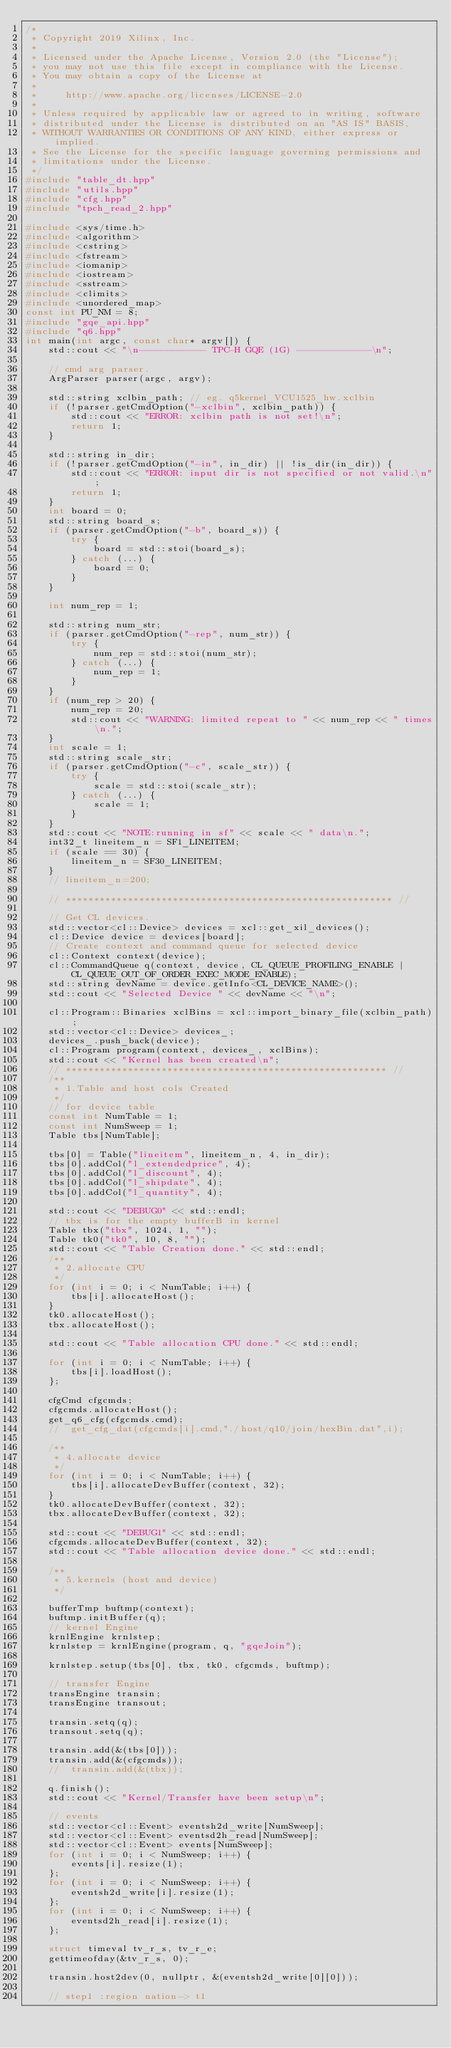Convert code to text. <code><loc_0><loc_0><loc_500><loc_500><_C++_>/*
 * Copyright 2019 Xilinx, Inc.
 *
 * Licensed under the Apache License, Version 2.0 (the "License");
 * you may not use this file except in compliance with the License.
 * You may obtain a copy of the License at
 *
 *     http://www.apache.org/licenses/LICENSE-2.0
 *
 * Unless required by applicable law or agreed to in writing, software
 * distributed under the License is distributed on an "AS IS" BASIS,
 * WITHOUT WARRANTIES OR CONDITIONS OF ANY KIND, either express or implied.
 * See the License for the specific language governing permissions and
 * limitations under the License.
 */
#include "table_dt.hpp"
#include "utils.hpp"
#include "cfg.hpp"
#include "tpch_read_2.hpp"

#include <sys/time.h>
#include <algorithm>
#include <cstring>
#include <fstream>
#include <iomanip>
#include <iostream>
#include <sstream>
#include <climits>
#include <unordered_map>
const int PU_NM = 8;
#include "gqe_api.hpp"
#include "q6.hpp"
int main(int argc, const char* argv[]) {
    std::cout << "\n------------ TPC-H GQE (1G) -------------\n";

    // cmd arg parser.
    ArgParser parser(argc, argv);

    std::string xclbin_path; // eg. q5kernel_VCU1525_hw.xclbin
    if (!parser.getCmdOption("-xclbin", xclbin_path)) {
        std::cout << "ERROR: xclbin path is not set!\n";
        return 1;
    }

    std::string in_dir;
    if (!parser.getCmdOption("-in", in_dir) || !is_dir(in_dir)) {
        std::cout << "ERROR: input dir is not specified or not valid.\n";
        return 1;
    }
    int board = 0;
    std::string board_s;
    if (parser.getCmdOption("-b", board_s)) {
        try {
            board = std::stoi(board_s);
        } catch (...) {
            board = 0;
        }
    }

    int num_rep = 1;

    std::string num_str;
    if (parser.getCmdOption("-rep", num_str)) {
        try {
            num_rep = std::stoi(num_str);
        } catch (...) {
            num_rep = 1;
        }
    }
    if (num_rep > 20) {
        num_rep = 20;
        std::cout << "WARNING: limited repeat to " << num_rep << " times\n.";
    }
    int scale = 1;
    std::string scale_str;
    if (parser.getCmdOption("-c", scale_str)) {
        try {
            scale = std::stoi(scale_str);
        } catch (...) {
            scale = 1;
        }
    }
    std::cout << "NOTE:running in sf" << scale << " data\n.";
    int32_t lineitem_n = SF1_LINEITEM;
    if (scale == 30) {
        lineitem_n = SF30_LINEITEM;
    }
    // lineitem_n=200;

    // ********************************************************** //

    // Get CL devices.
    std::vector<cl::Device> devices = xcl::get_xil_devices();
    cl::Device device = devices[board];
    // Create context and command queue for selected device
    cl::Context context(device);
    cl::CommandQueue q(context, device, CL_QUEUE_PROFILING_ENABLE | CL_QUEUE_OUT_OF_ORDER_EXEC_MODE_ENABLE);
    std::string devName = device.getInfo<CL_DEVICE_NAME>();
    std::cout << "Selected Device " << devName << "\n";

    cl::Program::Binaries xclBins = xcl::import_binary_file(xclbin_path);
    std::vector<cl::Device> devices_;
    devices_.push_back(device);
    cl::Program program(context, devices_, xclBins);
    std::cout << "Kernel has been created\n";
    // ********************************************************* //
    /**
     * 1.Table and host cols Created
     */
    // for device table
    const int NumTable = 1;
    const int NumSweep = 1;
    Table tbs[NumTable];

    tbs[0] = Table("lineitem", lineitem_n, 4, in_dir);
    tbs[0].addCol("l_extendedprice", 4);
    tbs[0].addCol("l_discount", 4);
    tbs[0].addCol("l_shipdate", 4);
    tbs[0].addCol("l_quantity", 4);

    std::cout << "DEBUG0" << std::endl;
    // tbx is for the empty bufferB in kernel
    Table tbx("tbx", 1024, 1, "");
    Table tk0("tk0", 10, 8, "");
    std::cout << "Table Creation done." << std::endl;
    /**
     * 2.allocate CPU
     */
    for (int i = 0; i < NumTable; i++) {
        tbs[i].allocateHost();
    }
    tk0.allocateHost();
    tbx.allocateHost();

    std::cout << "Table allocation CPU done." << std::endl;

    for (int i = 0; i < NumTable; i++) {
        tbs[i].loadHost();
    };

    cfgCmd cfgcmds;
    cfgcmds.allocateHost();
    get_q6_cfg(cfgcmds.cmd);
    //  get_cfg_dat(cfgcmds[i].cmd,"./host/q10/join/hexBin.dat",i);

    /**
     * 4.allocate device
     */
    for (int i = 0; i < NumTable; i++) {
        tbs[i].allocateDevBuffer(context, 32);
    }
    tk0.allocateDevBuffer(context, 32);
    tbx.allocateDevBuffer(context, 32);

    std::cout << "DEBUG1" << std::endl;
    cfgcmds.allocateDevBuffer(context, 32);
    std::cout << "Table allocation device done." << std::endl;

    /**
     * 5.kernels (host and device)
     */

    bufferTmp buftmp(context);
    buftmp.initBuffer(q);
    // kernel Engine
    krnlEngine krnlstep;
    krnlstep = krnlEngine(program, q, "gqeJoin");

    krnlstep.setup(tbs[0], tbx, tk0, cfgcmds, buftmp);

    // transfer Engine
    transEngine transin;
    transEngine transout;

    transin.setq(q);
    transout.setq(q);

    transin.add(&(tbs[0]));
    transin.add(&(cfgcmds));
    //  transin.add(&(tbx));

    q.finish();
    std::cout << "Kernel/Transfer have been setup\n";

    // events
    std::vector<cl::Event> eventsh2d_write[NumSweep];
    std::vector<cl::Event> eventsd2h_read[NumSweep];
    std::vector<cl::Event> events[NumSweep];
    for (int i = 0; i < NumSweep; i++) {
        events[i].resize(1);
    };
    for (int i = 0; i < NumSweep; i++) {
        eventsh2d_write[i].resize(1);
    };
    for (int i = 0; i < NumSweep; i++) {
        eventsd2h_read[i].resize(1);
    };

    struct timeval tv_r_s, tv_r_e;
    gettimeofday(&tv_r_s, 0);

    transin.host2dev(0, nullptr, &(eventsh2d_write[0][0]));

    // step1 :region nation-> t1</code> 